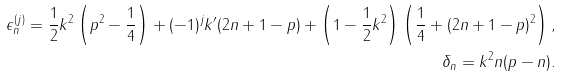<formula> <loc_0><loc_0><loc_500><loc_500>\epsilon _ { n } ^ { ( j ) } = \frac { 1 } { 2 } k ^ { 2 } \left ( p ^ { 2 } - \frac { 1 } { 4 } \right ) + ( - 1 ) ^ { j } k ^ { \prime } ( 2 n + 1 - p ) + \left ( 1 - \frac { 1 } { 2 } k ^ { 2 } \right ) \left ( \frac { 1 } { 4 } + ( 2 n + 1 - p ) ^ { 2 } \right ) , \\ \delta _ { n } = k ^ { 2 } n ( p - n ) .</formula> 